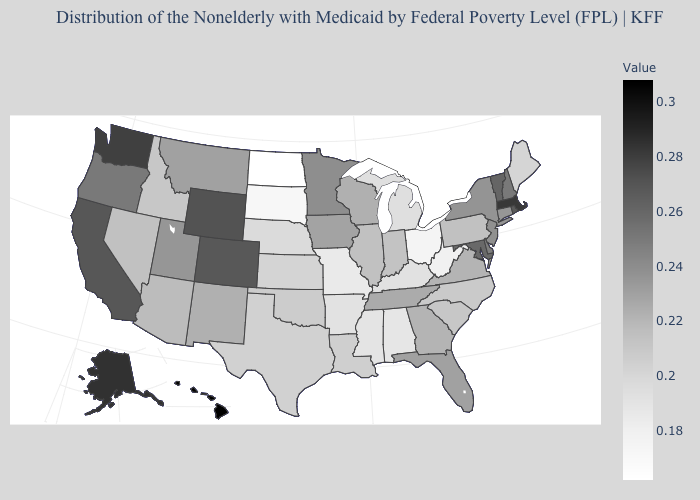Among the states that border Maryland , does Delaware have the highest value?
Be succinct. Yes. Which states have the lowest value in the West?
Write a very short answer. Idaho. Which states have the lowest value in the USA?
Quick response, please. North Dakota. Is the legend a continuous bar?
Concise answer only. Yes. Among the states that border Nevada , does Arizona have the highest value?
Keep it brief. No. Does Massachusetts have the highest value in the Northeast?
Quick response, please. Yes. 